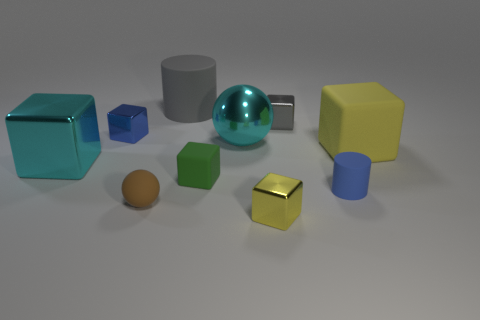Subtract all yellow rubber cubes. How many cubes are left? 5 Subtract all cyan cubes. How many cubes are left? 5 Subtract all gray spheres. Subtract all brown cubes. How many spheres are left? 2 Subtract all tiny gray things. Subtract all gray shiny cubes. How many objects are left? 8 Add 4 cubes. How many cubes are left? 10 Add 9 small blue cylinders. How many small blue cylinders exist? 10 Subtract 0 purple balls. How many objects are left? 10 Subtract all blocks. How many objects are left? 4 